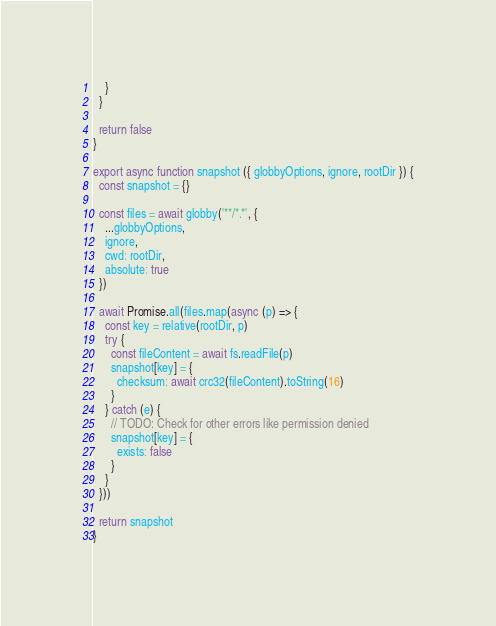Convert code to text. <code><loc_0><loc_0><loc_500><loc_500><_JavaScript_>    }
  }

  return false
}

export async function snapshot ({ globbyOptions, ignore, rootDir }) {
  const snapshot = {}

  const files = await globby('**/*.*', {
    ...globbyOptions,
    ignore,
    cwd: rootDir,
    absolute: true
  })

  await Promise.all(files.map(async (p) => {
    const key = relative(rootDir, p)
    try {
      const fileContent = await fs.readFile(p)
      snapshot[key] = {
        checksum: await crc32(fileContent).toString(16)
      }
    } catch (e) {
      // TODO: Check for other errors like permission denied
      snapshot[key] = {
        exists: false
      }
    }
  }))

  return snapshot
}
</code> 